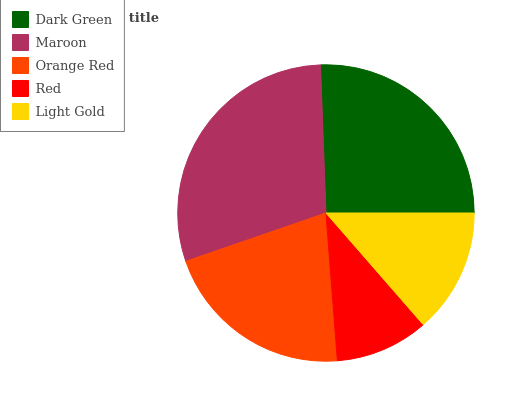Is Red the minimum?
Answer yes or no. Yes. Is Maroon the maximum?
Answer yes or no. Yes. Is Orange Red the minimum?
Answer yes or no. No. Is Orange Red the maximum?
Answer yes or no. No. Is Maroon greater than Orange Red?
Answer yes or no. Yes. Is Orange Red less than Maroon?
Answer yes or no. Yes. Is Orange Red greater than Maroon?
Answer yes or no. No. Is Maroon less than Orange Red?
Answer yes or no. No. Is Orange Red the high median?
Answer yes or no. Yes. Is Orange Red the low median?
Answer yes or no. Yes. Is Maroon the high median?
Answer yes or no. No. Is Dark Green the low median?
Answer yes or no. No. 